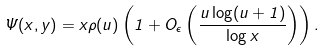Convert formula to latex. <formula><loc_0><loc_0><loc_500><loc_500>\Psi ( x , y ) = x \rho ( u ) \left ( 1 + O _ { \epsilon } \left ( \frac { u \log ( u + 1 ) } { \log x } \right ) \right ) .</formula> 